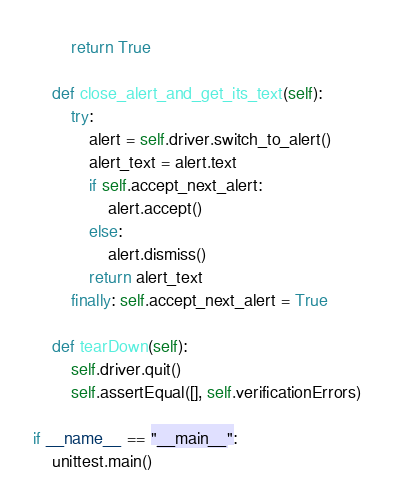<code> <loc_0><loc_0><loc_500><loc_500><_Python_>        return True
    
    def close_alert_and_get_its_text(self):
        try:
            alert = self.driver.switch_to_alert()
            alert_text = alert.text
            if self.accept_next_alert:
                alert.accept()
            else:
                alert.dismiss()
            return alert_text
        finally: self.accept_next_alert = True
    
    def tearDown(self):
        self.driver.quit()
        self.assertEqual([], self.verificationErrors)

if __name__ == "__main__":
    unittest.main()
</code> 